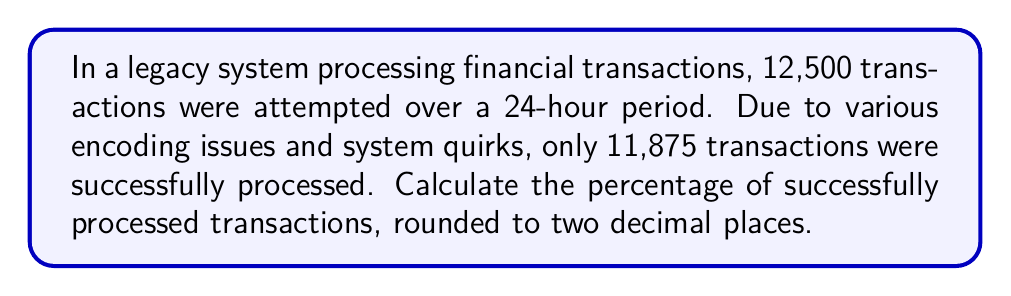Provide a solution to this math problem. To calculate the percentage of successfully processed transactions, we need to follow these steps:

1. Identify the total number of attempted transactions:
   $Total_{transactions} = 12,500$

2. Identify the number of successfully processed transactions:
   $Successful_{transactions} = 11,875$

3. Calculate the ratio of successful transactions to total transactions:
   $Ratio = \frac{Successful_{transactions}}{Total_{transactions}} = \frac{11,875}{12,500}$

4. Convert the ratio to a percentage by multiplying by 100:
   $Percentage = Ratio \times 100 = \frac{11,875}{12,500} \times 100$

5. Perform the division:
   $\frac{11,875}{12,500} = 0.95$

6. Multiply by 100:
   $0.95 \times 100 = 95$

7. Round to two decimal places:
   $95.00\%$

Therefore, the percentage of successfully processed transactions is 95.00%.
Answer: 95.00% 